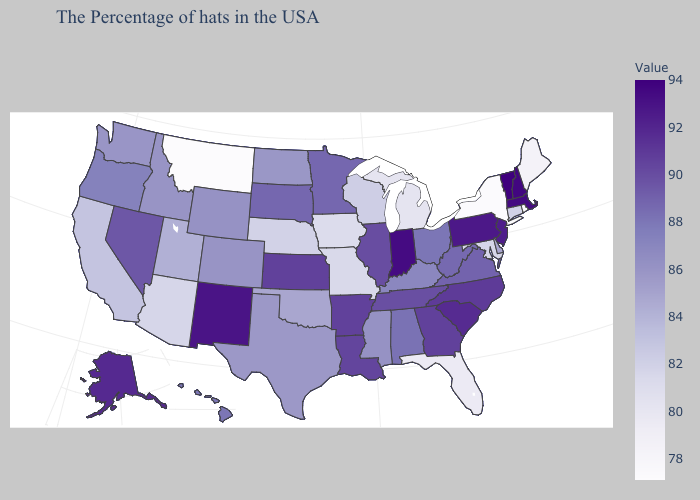Does the map have missing data?
Concise answer only. No. Does Vermont have the highest value in the USA?
Keep it brief. Yes. Which states have the lowest value in the MidWest?
Be succinct. Michigan. Is the legend a continuous bar?
Give a very brief answer. Yes. Which states have the lowest value in the USA?
Short answer required. Montana. Which states have the lowest value in the Northeast?
Be succinct. New York. Among the states that border Tennessee , does Mississippi have the lowest value?
Keep it brief. No. Among the states that border Oklahoma , does New Mexico have the highest value?
Quick response, please. Yes. 